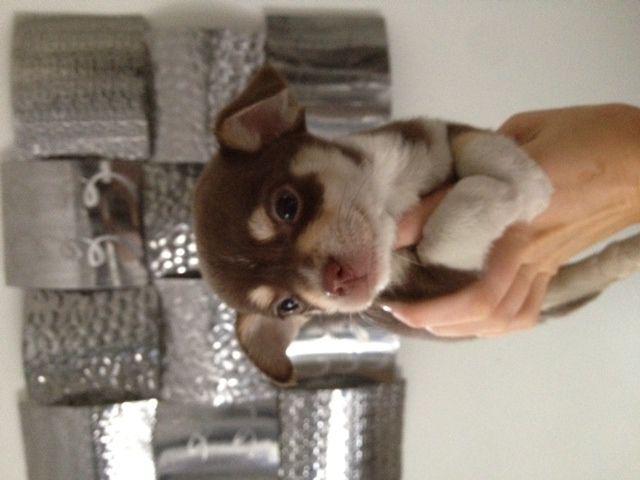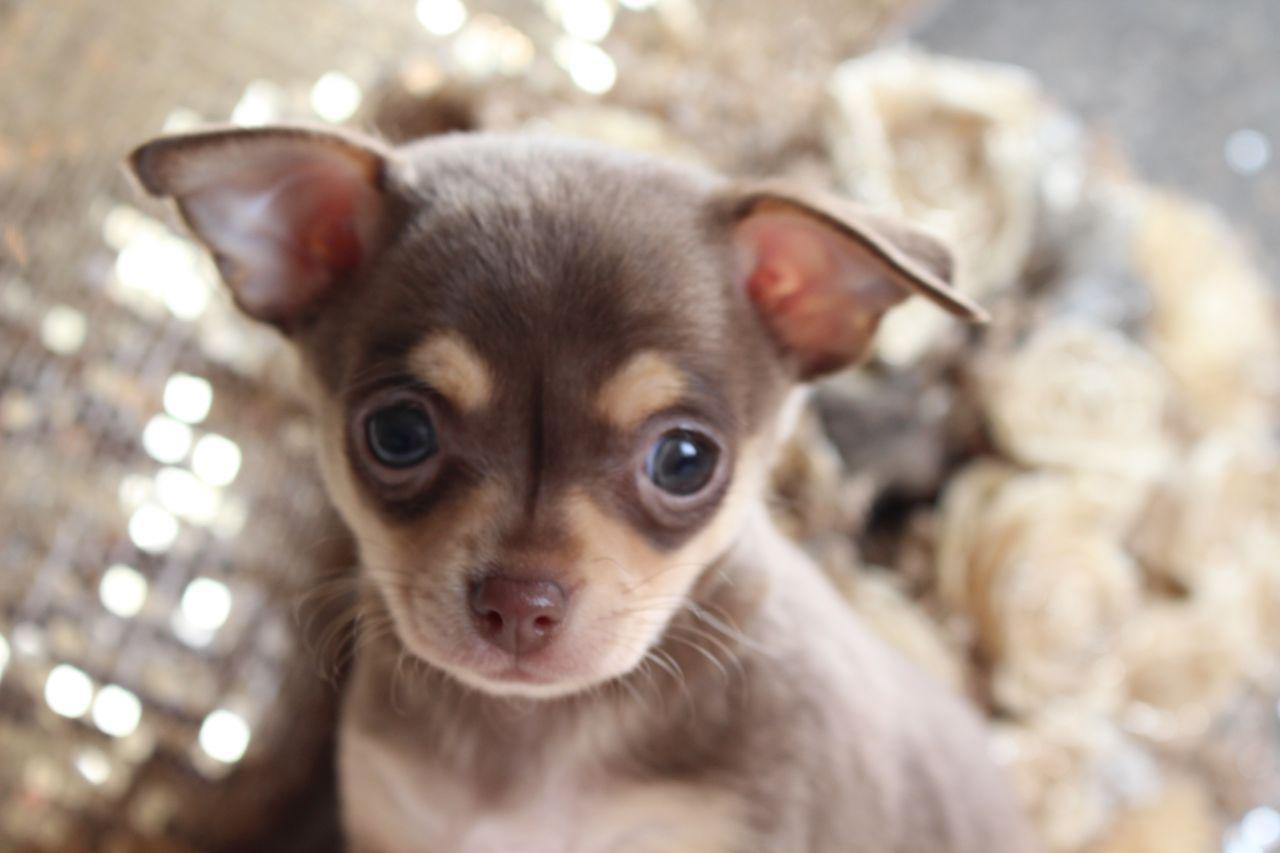The first image is the image on the left, the second image is the image on the right. Evaluate the accuracy of this statement regarding the images: "A human hand is touching a small dog in one image.". Is it true? Answer yes or no. Yes. The first image is the image on the left, the second image is the image on the right. For the images shown, is this caption "There are two chihuahua puppies" true? Answer yes or no. Yes. 